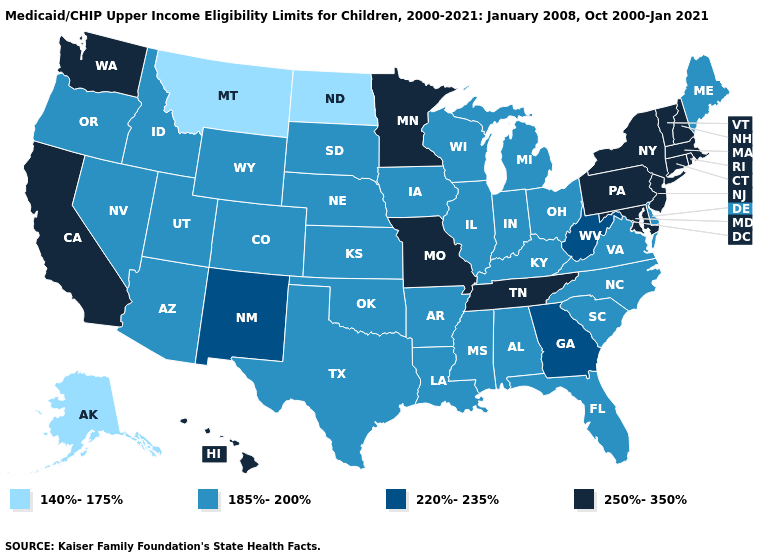What is the lowest value in states that border West Virginia?
Keep it brief. 185%-200%. Name the states that have a value in the range 185%-200%?
Short answer required. Alabama, Arizona, Arkansas, Colorado, Delaware, Florida, Idaho, Illinois, Indiana, Iowa, Kansas, Kentucky, Louisiana, Maine, Michigan, Mississippi, Nebraska, Nevada, North Carolina, Ohio, Oklahoma, Oregon, South Carolina, South Dakota, Texas, Utah, Virginia, Wisconsin, Wyoming. What is the lowest value in states that border Arkansas?
Give a very brief answer. 185%-200%. Which states have the lowest value in the MidWest?
Write a very short answer. North Dakota. Which states hav the highest value in the MidWest?
Answer briefly. Minnesota, Missouri. Among the states that border Virginia , does West Virginia have the highest value?
Keep it brief. No. Does South Dakota have a lower value than Kansas?
Give a very brief answer. No. Name the states that have a value in the range 220%-235%?
Keep it brief. Georgia, New Mexico, West Virginia. What is the value of Louisiana?
Short answer required. 185%-200%. What is the value of Kentucky?
Concise answer only. 185%-200%. What is the value of Delaware?
Short answer required. 185%-200%. Name the states that have a value in the range 220%-235%?
Quick response, please. Georgia, New Mexico, West Virginia. Does Tennessee have the highest value in the South?
Be succinct. Yes. Among the states that border Illinois , which have the lowest value?
Give a very brief answer. Indiana, Iowa, Kentucky, Wisconsin. Does Oklahoma have the highest value in the USA?
Keep it brief. No. 